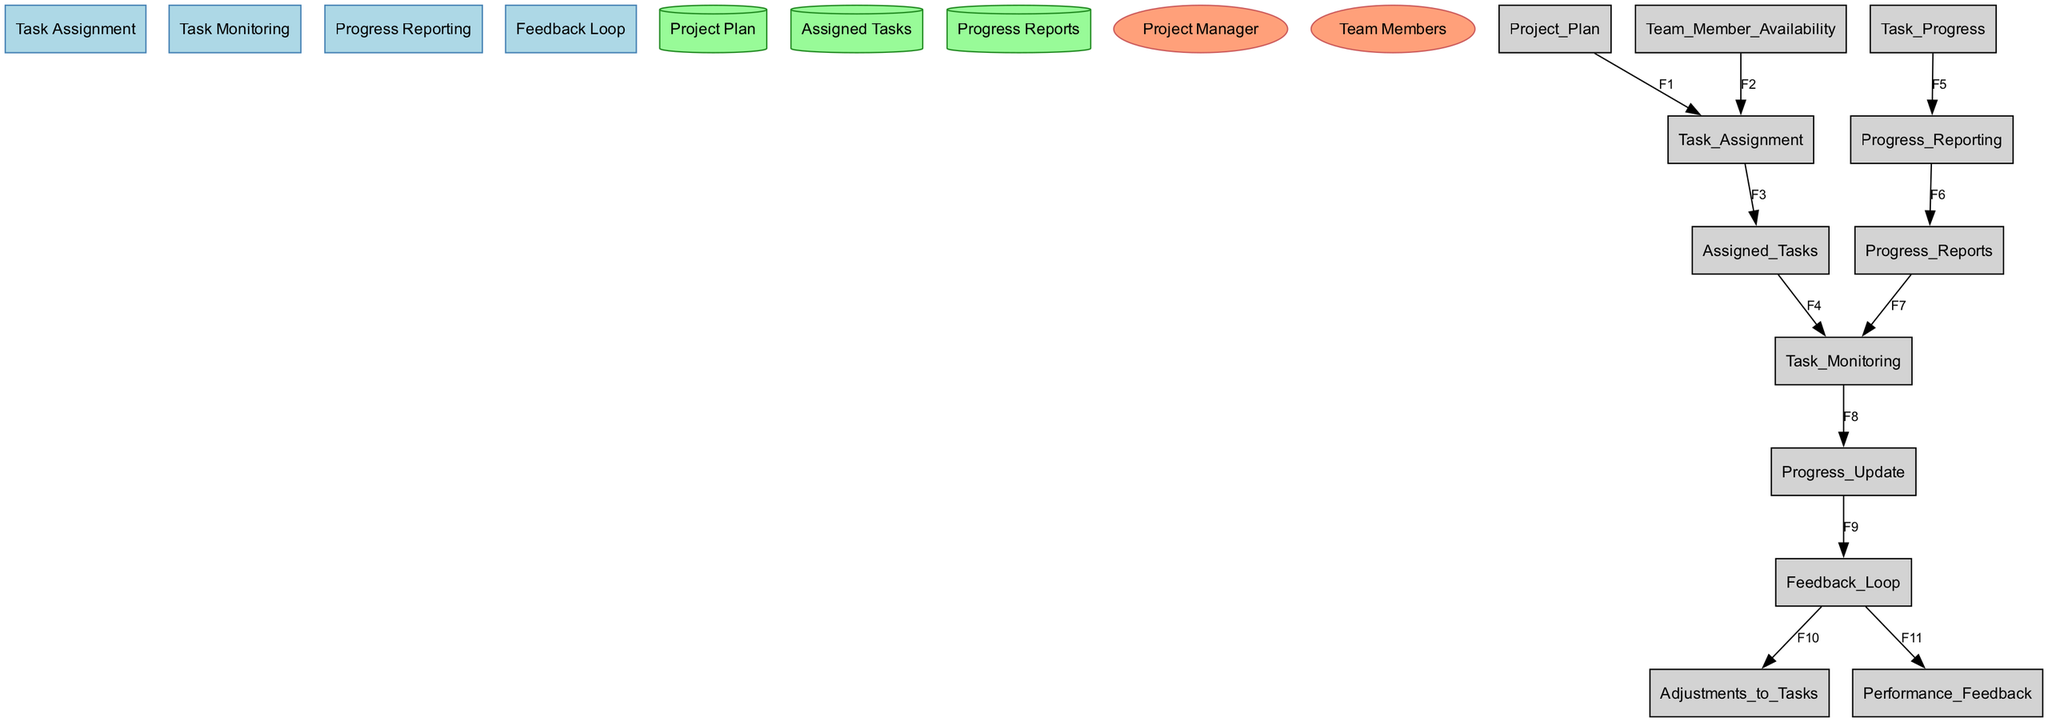What is the first process in the workflow? The first process in the diagram is identified as "Task Assignment" since it is the first listed process in the data provided.
Answer: Task Assignment Who participates in the "Feedback Loop"? According to the data, the only participant specified for the "Feedback Loop" process is the "Project Manager."
Answer: Project Manager How many data stores are present in the diagram? The diagram lists three data stores: "Project Plan," "Assigned Tasks," and "Progress Reports." Thus, the total count can be derived directly from the count of entries in the 'data_stores' section.
Answer: Three What is the output of the "Progress Reporting" process? The output of the "Progress Reporting" process is explicitly stated to be "Progress Reports," which is clearly noted in the data associated with this process.
Answer: Progress Reports Which process receives inputs from "Assigned Tasks"? Looking at the data flows, the "Task Monitoring" process receives inputs from "Assigned Tasks," as indicated by flow F4. Therefore, the answer can be derived by identifying which process is next in the data flow.
Answer: Task Monitoring How many external entities are involved in this workflow? The provided data mentions two external entities: "Project Manager" and "Team Members," allowing us to directly count them.
Answer: Two What are the outputs of the "Feedback Loop" process? The outputs of the "Feedback Loop" process are "Adjustments to Tasks" and "Performance Feedback." These are explicitly listed as outputs in the provided details about the process.
Answer: Adjustments to Tasks, Performance Feedback Which data flow connects the "Task Monitoring" and "Feedback Loop" processes? The data flow that connects these processes is labeled F9, which shows that "Progress Update" is passed from "Task Monitoring" to "Feedback Loop." This can be confirmed by checking the flows section.
Answer: F9 